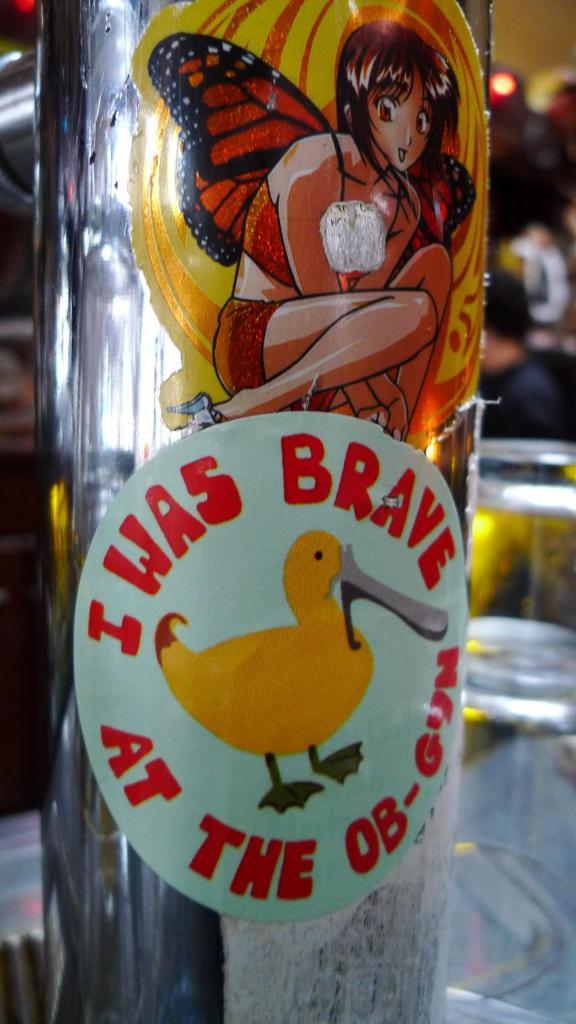Where was the image taken? The image was taken indoors. What furniture is present in the image? There is a table in the image. What objects are on the table? There is a bottle and glasses on the table. How much was the payment for the board in the image? There is no board or payment present in the image. 